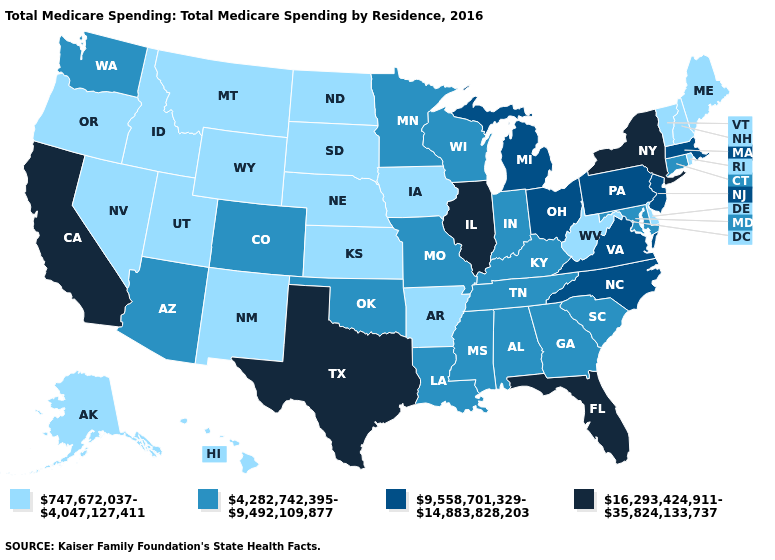Among the states that border Iowa , does South Dakota have the highest value?
Short answer required. No. Name the states that have a value in the range 747,672,037-4,047,127,411?
Quick response, please. Alaska, Arkansas, Delaware, Hawaii, Idaho, Iowa, Kansas, Maine, Montana, Nebraska, Nevada, New Hampshire, New Mexico, North Dakota, Oregon, Rhode Island, South Dakota, Utah, Vermont, West Virginia, Wyoming. How many symbols are there in the legend?
Give a very brief answer. 4. Name the states that have a value in the range 16,293,424,911-35,824,133,737?
Write a very short answer. California, Florida, Illinois, New York, Texas. Does Utah have the lowest value in the West?
Concise answer only. Yes. What is the value of Alaska?
Quick response, please. 747,672,037-4,047,127,411. Which states have the lowest value in the USA?
Be succinct. Alaska, Arkansas, Delaware, Hawaii, Idaho, Iowa, Kansas, Maine, Montana, Nebraska, Nevada, New Hampshire, New Mexico, North Dakota, Oregon, Rhode Island, South Dakota, Utah, Vermont, West Virginia, Wyoming. Which states have the lowest value in the South?
Quick response, please. Arkansas, Delaware, West Virginia. Does Delaware have the same value as Maine?
Keep it brief. Yes. Among the states that border Massachusetts , does Vermont have the lowest value?
Be succinct. Yes. Name the states that have a value in the range 16,293,424,911-35,824,133,737?
Quick response, please. California, Florida, Illinois, New York, Texas. Among the states that border Wyoming , which have the highest value?
Short answer required. Colorado. Among the states that border Maryland , which have the lowest value?
Be succinct. Delaware, West Virginia. Name the states that have a value in the range 4,282,742,395-9,492,109,877?
Write a very short answer. Alabama, Arizona, Colorado, Connecticut, Georgia, Indiana, Kentucky, Louisiana, Maryland, Minnesota, Mississippi, Missouri, Oklahoma, South Carolina, Tennessee, Washington, Wisconsin. Among the states that border New Jersey , does New York have the lowest value?
Keep it brief. No. 